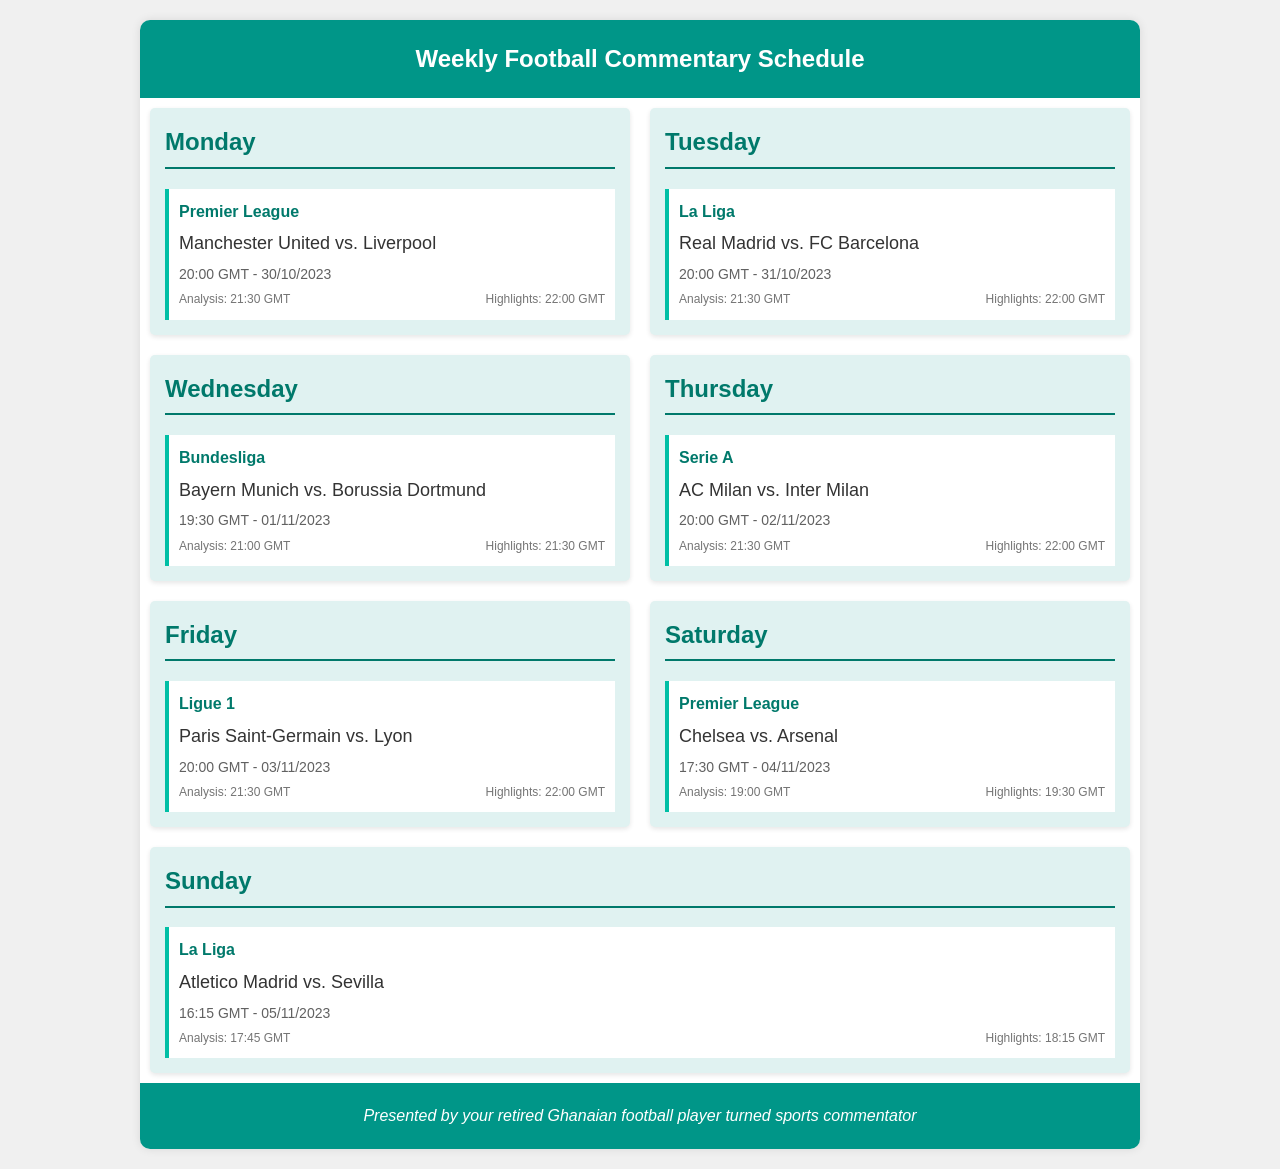What match is scheduled on Monday? The match scheduled on Monday is between Manchester United and Liverpool.
Answer: Manchester United vs. Liverpool What time does the analysis start for the Real Madrid vs. FC Barcelona match? The analysis for the Real Madrid vs. FC Barcelona match starts at 21:30 GMT.
Answer: 21:30 GMT Which league features the match between Bayern Munich and Borussia Dortmund? The match between Bayern Munich and Borussia Dortmund is in the Bundesliga.
Answer: Bundesliga On what date will the Chelsea vs. Arsenal match take place? The Chelsea vs. Arsenal match is scheduled for 04/11/2023.
Answer: 04/11/2023 What is the highlight time for the Atletico Madrid vs. Sevilla match? The highlights for the Atletico Madrid vs. Sevilla match are at 18:15 GMT.
Answer: 18:15 GMT Which day is the Ligue 1 match scheduled? The Ligue 1 match is scheduled on Friday.
Answer: Friday How many matches take place on Sunday? There is one match scheduled on Sunday.
Answer: One What is the time of the match between AC Milan and Inter Milan? The match between AC Milan and Inter Milan is at 20:00 GMT.
Answer: 20:00 GMT What is the total number of matches listed in the schedule? There are seven matches listed in the schedule for the week.
Answer: Seven 